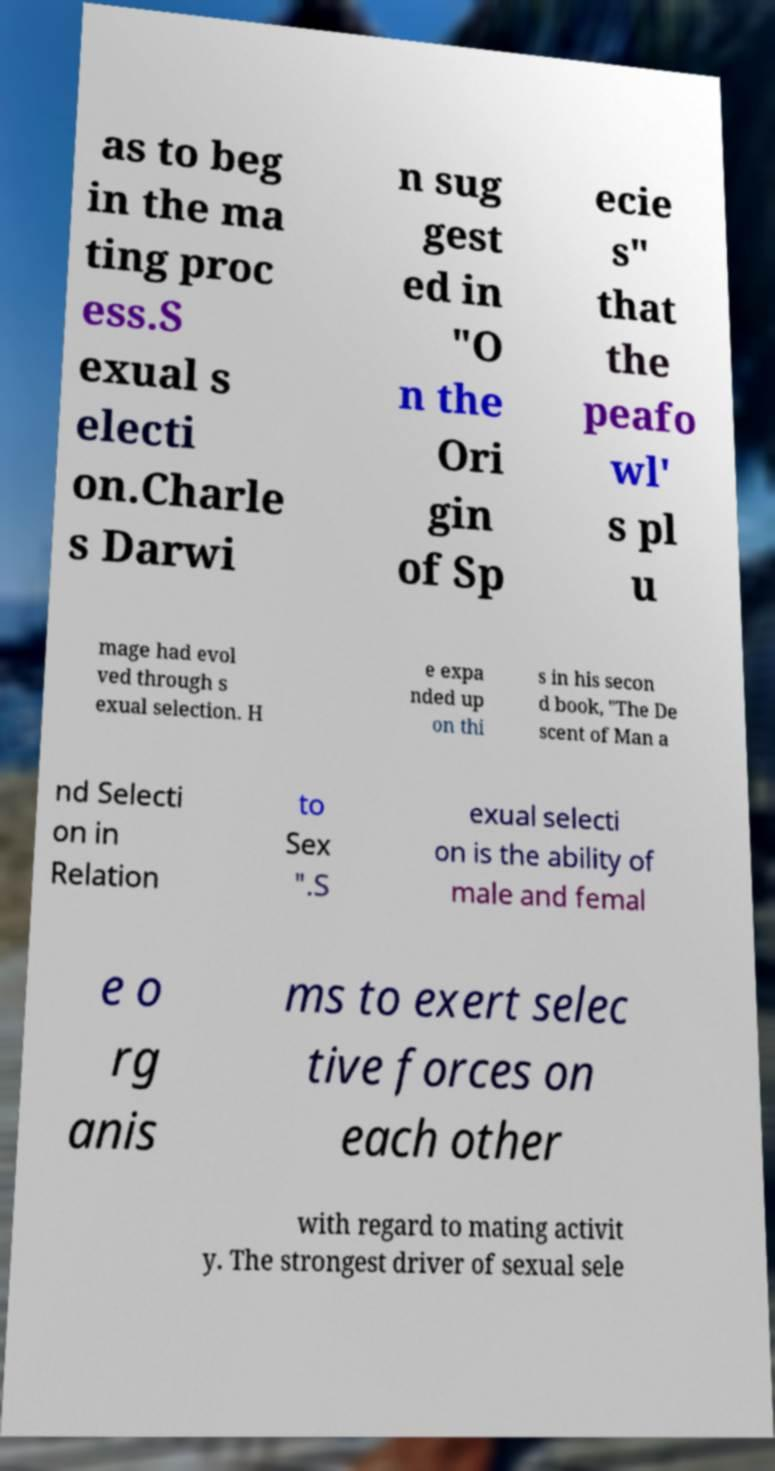There's text embedded in this image that I need extracted. Can you transcribe it verbatim? as to beg in the ma ting proc ess.S exual s electi on.Charle s Darwi n sug gest ed in "O n the Ori gin of Sp ecie s" that the peafo wl' s pl u mage had evol ved through s exual selection. H e expa nded up on thi s in his secon d book, "The De scent of Man a nd Selecti on in Relation to Sex ".S exual selecti on is the ability of male and femal e o rg anis ms to exert selec tive forces on each other with regard to mating activit y. The strongest driver of sexual sele 